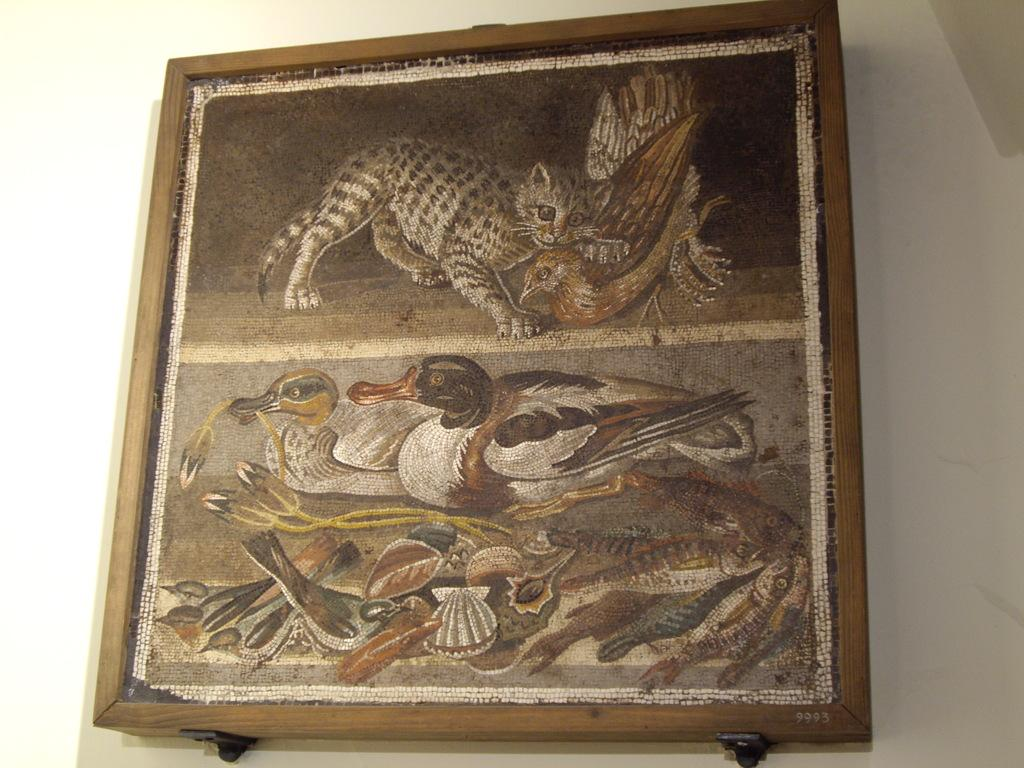What object is present in the image that typically holds a picture? There is a photo frame in the image. What is depicted in the photo frame? The photo frame contains a picture of ducks and a cat. What can be seen behind the photo frame in the image? There is a wall in the background of the image. What type of rake is being used to clean the ducks in the image? There is no rake present in the image, and the ducks are part of a picture within the photo frame. 